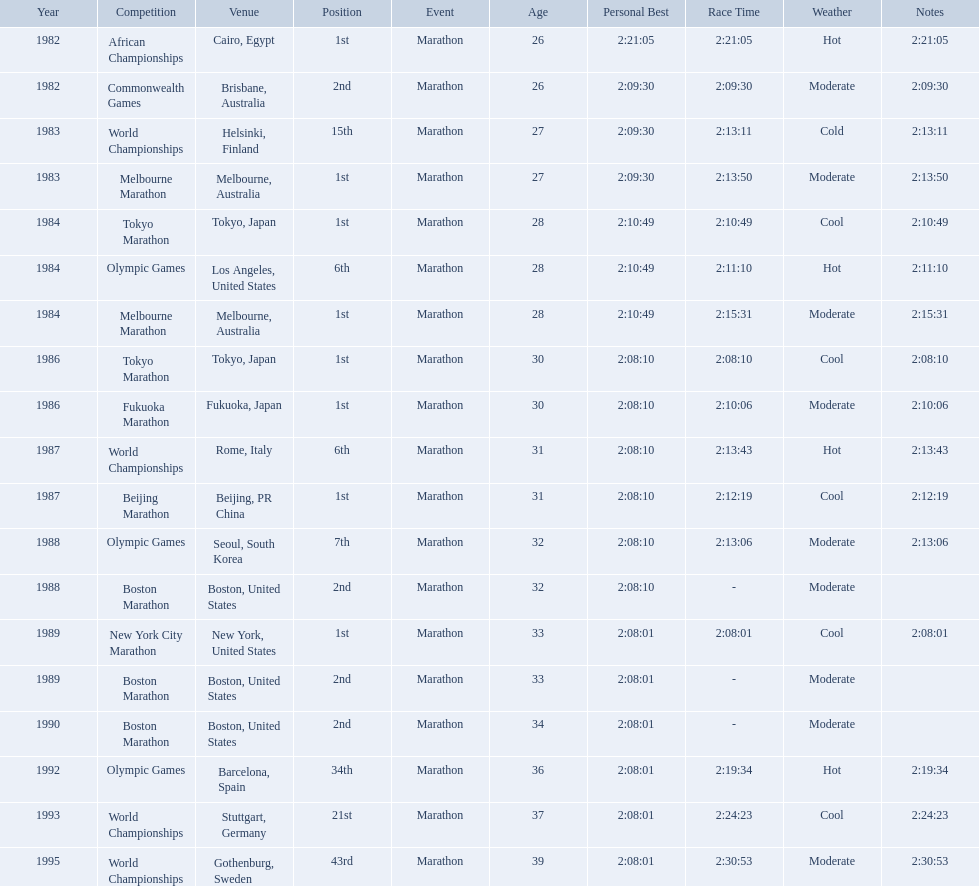What are all the competitions? African Championships, Commonwealth Games, World Championships, Melbourne Marathon, Tokyo Marathon, Olympic Games, Melbourne Marathon, Tokyo Marathon, Fukuoka Marathon, World Championships, Beijing Marathon, Olympic Games, Boston Marathon, New York City Marathon, Boston Marathon, Boston Marathon, Olympic Games, World Championships, World Championships. Where were they located? Cairo, Egypt, Brisbane, Australia, Helsinki, Finland, Melbourne, Australia, Tokyo, Japan, Los Angeles, United States, Melbourne, Australia, Tokyo, Japan, Fukuoka, Japan, Rome, Italy, Beijing, PR China, Seoul, South Korea, Boston, United States, New York, United States, Boston, United States, Boston, United States, Barcelona, Spain, Stuttgart, Germany, Gothenburg, Sweden. And which competition was in china? Beijing Marathon. What are all of the juma ikangaa competitions? African Championships, Commonwealth Games, World Championships, Melbourne Marathon, Tokyo Marathon, Olympic Games, Melbourne Marathon, Tokyo Marathon, Fukuoka Marathon, World Championships, Beijing Marathon, Olympic Games, Boston Marathon, New York City Marathon, Boston Marathon, Boston Marathon, Olympic Games, World Championships, World Championships. Which of these competitions did not take place in the united states? African Championships, Commonwealth Games, World Championships, Melbourne Marathon, Tokyo Marathon, Melbourne Marathon, Tokyo Marathon, Fukuoka Marathon, World Championships, Beijing Marathon, Olympic Games, Olympic Games, World Championships, World Championships. Out of these, which of them took place in asia? Tokyo Marathon, Tokyo Marathon, Fukuoka Marathon, Beijing Marathon, Olympic Games. Which of the remaining competitions took place in china? Beijing Marathon. 